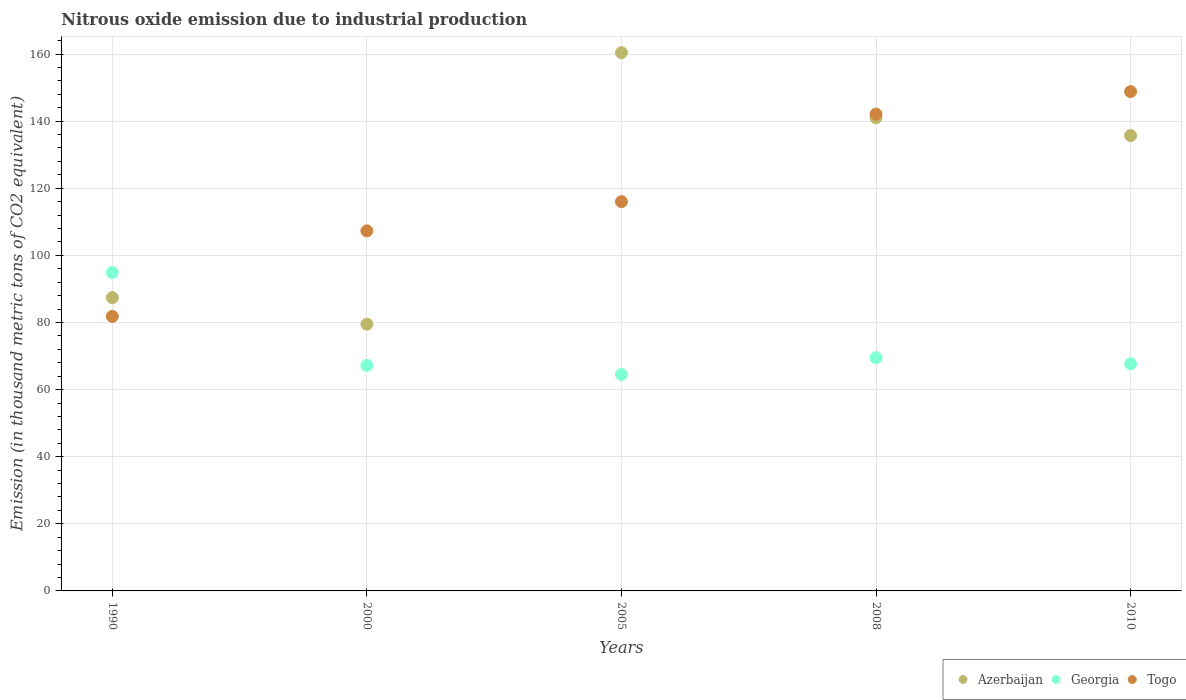What is the amount of nitrous oxide emitted in Georgia in 2000?
Your answer should be compact. 67.2. Across all years, what is the maximum amount of nitrous oxide emitted in Georgia?
Your response must be concise. 94.9. Across all years, what is the minimum amount of nitrous oxide emitted in Togo?
Keep it short and to the point. 81.8. In which year was the amount of nitrous oxide emitted in Azerbaijan maximum?
Your answer should be compact. 2005. In which year was the amount of nitrous oxide emitted in Azerbaijan minimum?
Your answer should be compact. 2000. What is the total amount of nitrous oxide emitted in Azerbaijan in the graph?
Make the answer very short. 604. What is the difference between the amount of nitrous oxide emitted in Azerbaijan in 1990 and that in 2010?
Your answer should be very brief. -48.3. What is the difference between the amount of nitrous oxide emitted in Togo in 2000 and the amount of nitrous oxide emitted in Georgia in 2010?
Ensure brevity in your answer.  39.6. What is the average amount of nitrous oxide emitted in Georgia per year?
Keep it short and to the point. 72.76. In the year 2010, what is the difference between the amount of nitrous oxide emitted in Togo and amount of nitrous oxide emitted in Georgia?
Your answer should be very brief. 81.1. In how many years, is the amount of nitrous oxide emitted in Georgia greater than 100 thousand metric tons?
Offer a very short reply. 0. What is the ratio of the amount of nitrous oxide emitted in Togo in 2008 to that in 2010?
Keep it short and to the point. 0.95. Is the amount of nitrous oxide emitted in Georgia in 2008 less than that in 2010?
Give a very brief answer. No. Is the difference between the amount of nitrous oxide emitted in Togo in 2000 and 2008 greater than the difference between the amount of nitrous oxide emitted in Georgia in 2000 and 2008?
Keep it short and to the point. No. What is the difference between the highest and the second highest amount of nitrous oxide emitted in Azerbaijan?
Provide a short and direct response. 19.4. What is the difference between the highest and the lowest amount of nitrous oxide emitted in Togo?
Offer a terse response. 67. Is the sum of the amount of nitrous oxide emitted in Togo in 2000 and 2005 greater than the maximum amount of nitrous oxide emitted in Georgia across all years?
Give a very brief answer. Yes. Does the amount of nitrous oxide emitted in Togo monotonically increase over the years?
Your response must be concise. Yes. Is the amount of nitrous oxide emitted in Azerbaijan strictly greater than the amount of nitrous oxide emitted in Togo over the years?
Ensure brevity in your answer.  No. Is the amount of nitrous oxide emitted in Togo strictly less than the amount of nitrous oxide emitted in Azerbaijan over the years?
Offer a terse response. No. How many dotlines are there?
Provide a short and direct response. 3. How many years are there in the graph?
Your response must be concise. 5. Are the values on the major ticks of Y-axis written in scientific E-notation?
Make the answer very short. No. Where does the legend appear in the graph?
Your answer should be compact. Bottom right. How many legend labels are there?
Provide a short and direct response. 3. How are the legend labels stacked?
Offer a very short reply. Horizontal. What is the title of the graph?
Offer a very short reply. Nitrous oxide emission due to industrial production. What is the label or title of the Y-axis?
Give a very brief answer. Emission (in thousand metric tons of CO2 equivalent). What is the Emission (in thousand metric tons of CO2 equivalent) of Azerbaijan in 1990?
Offer a terse response. 87.4. What is the Emission (in thousand metric tons of CO2 equivalent) of Georgia in 1990?
Make the answer very short. 94.9. What is the Emission (in thousand metric tons of CO2 equivalent) of Togo in 1990?
Provide a short and direct response. 81.8. What is the Emission (in thousand metric tons of CO2 equivalent) in Azerbaijan in 2000?
Ensure brevity in your answer.  79.5. What is the Emission (in thousand metric tons of CO2 equivalent) in Georgia in 2000?
Ensure brevity in your answer.  67.2. What is the Emission (in thousand metric tons of CO2 equivalent) in Togo in 2000?
Provide a succinct answer. 107.3. What is the Emission (in thousand metric tons of CO2 equivalent) in Azerbaijan in 2005?
Provide a succinct answer. 160.4. What is the Emission (in thousand metric tons of CO2 equivalent) of Georgia in 2005?
Offer a very short reply. 64.5. What is the Emission (in thousand metric tons of CO2 equivalent) in Togo in 2005?
Keep it short and to the point. 116. What is the Emission (in thousand metric tons of CO2 equivalent) in Azerbaijan in 2008?
Make the answer very short. 141. What is the Emission (in thousand metric tons of CO2 equivalent) in Georgia in 2008?
Give a very brief answer. 69.5. What is the Emission (in thousand metric tons of CO2 equivalent) of Togo in 2008?
Your response must be concise. 142.1. What is the Emission (in thousand metric tons of CO2 equivalent) of Azerbaijan in 2010?
Your response must be concise. 135.7. What is the Emission (in thousand metric tons of CO2 equivalent) in Georgia in 2010?
Offer a very short reply. 67.7. What is the Emission (in thousand metric tons of CO2 equivalent) in Togo in 2010?
Make the answer very short. 148.8. Across all years, what is the maximum Emission (in thousand metric tons of CO2 equivalent) in Azerbaijan?
Your answer should be very brief. 160.4. Across all years, what is the maximum Emission (in thousand metric tons of CO2 equivalent) of Georgia?
Provide a short and direct response. 94.9. Across all years, what is the maximum Emission (in thousand metric tons of CO2 equivalent) of Togo?
Provide a succinct answer. 148.8. Across all years, what is the minimum Emission (in thousand metric tons of CO2 equivalent) in Azerbaijan?
Provide a short and direct response. 79.5. Across all years, what is the minimum Emission (in thousand metric tons of CO2 equivalent) of Georgia?
Give a very brief answer. 64.5. Across all years, what is the minimum Emission (in thousand metric tons of CO2 equivalent) in Togo?
Offer a terse response. 81.8. What is the total Emission (in thousand metric tons of CO2 equivalent) of Azerbaijan in the graph?
Make the answer very short. 604. What is the total Emission (in thousand metric tons of CO2 equivalent) in Georgia in the graph?
Offer a terse response. 363.8. What is the total Emission (in thousand metric tons of CO2 equivalent) of Togo in the graph?
Your answer should be very brief. 596. What is the difference between the Emission (in thousand metric tons of CO2 equivalent) of Georgia in 1990 and that in 2000?
Provide a succinct answer. 27.7. What is the difference between the Emission (in thousand metric tons of CO2 equivalent) in Togo in 1990 and that in 2000?
Make the answer very short. -25.5. What is the difference between the Emission (in thousand metric tons of CO2 equivalent) of Azerbaijan in 1990 and that in 2005?
Provide a succinct answer. -73. What is the difference between the Emission (in thousand metric tons of CO2 equivalent) of Georgia in 1990 and that in 2005?
Keep it short and to the point. 30.4. What is the difference between the Emission (in thousand metric tons of CO2 equivalent) of Togo in 1990 and that in 2005?
Your answer should be very brief. -34.2. What is the difference between the Emission (in thousand metric tons of CO2 equivalent) in Azerbaijan in 1990 and that in 2008?
Your answer should be very brief. -53.6. What is the difference between the Emission (in thousand metric tons of CO2 equivalent) in Georgia in 1990 and that in 2008?
Make the answer very short. 25.4. What is the difference between the Emission (in thousand metric tons of CO2 equivalent) of Togo in 1990 and that in 2008?
Your answer should be very brief. -60.3. What is the difference between the Emission (in thousand metric tons of CO2 equivalent) in Azerbaijan in 1990 and that in 2010?
Your answer should be very brief. -48.3. What is the difference between the Emission (in thousand metric tons of CO2 equivalent) in Georgia in 1990 and that in 2010?
Provide a succinct answer. 27.2. What is the difference between the Emission (in thousand metric tons of CO2 equivalent) in Togo in 1990 and that in 2010?
Offer a terse response. -67. What is the difference between the Emission (in thousand metric tons of CO2 equivalent) of Azerbaijan in 2000 and that in 2005?
Ensure brevity in your answer.  -80.9. What is the difference between the Emission (in thousand metric tons of CO2 equivalent) of Georgia in 2000 and that in 2005?
Offer a very short reply. 2.7. What is the difference between the Emission (in thousand metric tons of CO2 equivalent) in Azerbaijan in 2000 and that in 2008?
Provide a succinct answer. -61.5. What is the difference between the Emission (in thousand metric tons of CO2 equivalent) of Georgia in 2000 and that in 2008?
Give a very brief answer. -2.3. What is the difference between the Emission (in thousand metric tons of CO2 equivalent) of Togo in 2000 and that in 2008?
Offer a terse response. -34.8. What is the difference between the Emission (in thousand metric tons of CO2 equivalent) of Azerbaijan in 2000 and that in 2010?
Keep it short and to the point. -56.2. What is the difference between the Emission (in thousand metric tons of CO2 equivalent) in Togo in 2000 and that in 2010?
Offer a very short reply. -41.5. What is the difference between the Emission (in thousand metric tons of CO2 equivalent) of Azerbaijan in 2005 and that in 2008?
Give a very brief answer. 19.4. What is the difference between the Emission (in thousand metric tons of CO2 equivalent) of Togo in 2005 and that in 2008?
Your answer should be compact. -26.1. What is the difference between the Emission (in thousand metric tons of CO2 equivalent) of Azerbaijan in 2005 and that in 2010?
Give a very brief answer. 24.7. What is the difference between the Emission (in thousand metric tons of CO2 equivalent) in Togo in 2005 and that in 2010?
Provide a succinct answer. -32.8. What is the difference between the Emission (in thousand metric tons of CO2 equivalent) in Togo in 2008 and that in 2010?
Offer a terse response. -6.7. What is the difference between the Emission (in thousand metric tons of CO2 equivalent) of Azerbaijan in 1990 and the Emission (in thousand metric tons of CO2 equivalent) of Georgia in 2000?
Provide a succinct answer. 20.2. What is the difference between the Emission (in thousand metric tons of CO2 equivalent) of Azerbaijan in 1990 and the Emission (in thousand metric tons of CO2 equivalent) of Togo in 2000?
Your response must be concise. -19.9. What is the difference between the Emission (in thousand metric tons of CO2 equivalent) of Georgia in 1990 and the Emission (in thousand metric tons of CO2 equivalent) of Togo in 2000?
Provide a short and direct response. -12.4. What is the difference between the Emission (in thousand metric tons of CO2 equivalent) in Azerbaijan in 1990 and the Emission (in thousand metric tons of CO2 equivalent) in Georgia in 2005?
Your answer should be compact. 22.9. What is the difference between the Emission (in thousand metric tons of CO2 equivalent) of Azerbaijan in 1990 and the Emission (in thousand metric tons of CO2 equivalent) of Togo in 2005?
Your answer should be compact. -28.6. What is the difference between the Emission (in thousand metric tons of CO2 equivalent) of Georgia in 1990 and the Emission (in thousand metric tons of CO2 equivalent) of Togo in 2005?
Offer a terse response. -21.1. What is the difference between the Emission (in thousand metric tons of CO2 equivalent) of Azerbaijan in 1990 and the Emission (in thousand metric tons of CO2 equivalent) of Togo in 2008?
Offer a very short reply. -54.7. What is the difference between the Emission (in thousand metric tons of CO2 equivalent) in Georgia in 1990 and the Emission (in thousand metric tons of CO2 equivalent) in Togo in 2008?
Your answer should be very brief. -47.2. What is the difference between the Emission (in thousand metric tons of CO2 equivalent) of Azerbaijan in 1990 and the Emission (in thousand metric tons of CO2 equivalent) of Togo in 2010?
Give a very brief answer. -61.4. What is the difference between the Emission (in thousand metric tons of CO2 equivalent) of Georgia in 1990 and the Emission (in thousand metric tons of CO2 equivalent) of Togo in 2010?
Your response must be concise. -53.9. What is the difference between the Emission (in thousand metric tons of CO2 equivalent) of Azerbaijan in 2000 and the Emission (in thousand metric tons of CO2 equivalent) of Georgia in 2005?
Give a very brief answer. 15. What is the difference between the Emission (in thousand metric tons of CO2 equivalent) of Azerbaijan in 2000 and the Emission (in thousand metric tons of CO2 equivalent) of Togo in 2005?
Keep it short and to the point. -36.5. What is the difference between the Emission (in thousand metric tons of CO2 equivalent) of Georgia in 2000 and the Emission (in thousand metric tons of CO2 equivalent) of Togo in 2005?
Your answer should be compact. -48.8. What is the difference between the Emission (in thousand metric tons of CO2 equivalent) of Azerbaijan in 2000 and the Emission (in thousand metric tons of CO2 equivalent) of Togo in 2008?
Provide a succinct answer. -62.6. What is the difference between the Emission (in thousand metric tons of CO2 equivalent) in Georgia in 2000 and the Emission (in thousand metric tons of CO2 equivalent) in Togo in 2008?
Provide a succinct answer. -74.9. What is the difference between the Emission (in thousand metric tons of CO2 equivalent) of Azerbaijan in 2000 and the Emission (in thousand metric tons of CO2 equivalent) of Georgia in 2010?
Provide a short and direct response. 11.8. What is the difference between the Emission (in thousand metric tons of CO2 equivalent) in Azerbaijan in 2000 and the Emission (in thousand metric tons of CO2 equivalent) in Togo in 2010?
Give a very brief answer. -69.3. What is the difference between the Emission (in thousand metric tons of CO2 equivalent) of Georgia in 2000 and the Emission (in thousand metric tons of CO2 equivalent) of Togo in 2010?
Your answer should be very brief. -81.6. What is the difference between the Emission (in thousand metric tons of CO2 equivalent) of Azerbaijan in 2005 and the Emission (in thousand metric tons of CO2 equivalent) of Georgia in 2008?
Make the answer very short. 90.9. What is the difference between the Emission (in thousand metric tons of CO2 equivalent) of Georgia in 2005 and the Emission (in thousand metric tons of CO2 equivalent) of Togo in 2008?
Ensure brevity in your answer.  -77.6. What is the difference between the Emission (in thousand metric tons of CO2 equivalent) in Azerbaijan in 2005 and the Emission (in thousand metric tons of CO2 equivalent) in Georgia in 2010?
Your response must be concise. 92.7. What is the difference between the Emission (in thousand metric tons of CO2 equivalent) of Azerbaijan in 2005 and the Emission (in thousand metric tons of CO2 equivalent) of Togo in 2010?
Ensure brevity in your answer.  11.6. What is the difference between the Emission (in thousand metric tons of CO2 equivalent) in Georgia in 2005 and the Emission (in thousand metric tons of CO2 equivalent) in Togo in 2010?
Make the answer very short. -84.3. What is the difference between the Emission (in thousand metric tons of CO2 equivalent) of Azerbaijan in 2008 and the Emission (in thousand metric tons of CO2 equivalent) of Georgia in 2010?
Provide a short and direct response. 73.3. What is the difference between the Emission (in thousand metric tons of CO2 equivalent) of Azerbaijan in 2008 and the Emission (in thousand metric tons of CO2 equivalent) of Togo in 2010?
Provide a succinct answer. -7.8. What is the difference between the Emission (in thousand metric tons of CO2 equivalent) of Georgia in 2008 and the Emission (in thousand metric tons of CO2 equivalent) of Togo in 2010?
Keep it short and to the point. -79.3. What is the average Emission (in thousand metric tons of CO2 equivalent) of Azerbaijan per year?
Ensure brevity in your answer.  120.8. What is the average Emission (in thousand metric tons of CO2 equivalent) in Georgia per year?
Provide a succinct answer. 72.76. What is the average Emission (in thousand metric tons of CO2 equivalent) of Togo per year?
Provide a short and direct response. 119.2. In the year 1990, what is the difference between the Emission (in thousand metric tons of CO2 equivalent) in Azerbaijan and Emission (in thousand metric tons of CO2 equivalent) in Togo?
Give a very brief answer. 5.6. In the year 1990, what is the difference between the Emission (in thousand metric tons of CO2 equivalent) of Georgia and Emission (in thousand metric tons of CO2 equivalent) of Togo?
Ensure brevity in your answer.  13.1. In the year 2000, what is the difference between the Emission (in thousand metric tons of CO2 equivalent) in Azerbaijan and Emission (in thousand metric tons of CO2 equivalent) in Togo?
Make the answer very short. -27.8. In the year 2000, what is the difference between the Emission (in thousand metric tons of CO2 equivalent) in Georgia and Emission (in thousand metric tons of CO2 equivalent) in Togo?
Your answer should be very brief. -40.1. In the year 2005, what is the difference between the Emission (in thousand metric tons of CO2 equivalent) in Azerbaijan and Emission (in thousand metric tons of CO2 equivalent) in Georgia?
Offer a terse response. 95.9. In the year 2005, what is the difference between the Emission (in thousand metric tons of CO2 equivalent) in Azerbaijan and Emission (in thousand metric tons of CO2 equivalent) in Togo?
Provide a short and direct response. 44.4. In the year 2005, what is the difference between the Emission (in thousand metric tons of CO2 equivalent) in Georgia and Emission (in thousand metric tons of CO2 equivalent) in Togo?
Give a very brief answer. -51.5. In the year 2008, what is the difference between the Emission (in thousand metric tons of CO2 equivalent) of Azerbaijan and Emission (in thousand metric tons of CO2 equivalent) of Georgia?
Ensure brevity in your answer.  71.5. In the year 2008, what is the difference between the Emission (in thousand metric tons of CO2 equivalent) in Azerbaijan and Emission (in thousand metric tons of CO2 equivalent) in Togo?
Your answer should be very brief. -1.1. In the year 2008, what is the difference between the Emission (in thousand metric tons of CO2 equivalent) in Georgia and Emission (in thousand metric tons of CO2 equivalent) in Togo?
Provide a short and direct response. -72.6. In the year 2010, what is the difference between the Emission (in thousand metric tons of CO2 equivalent) of Georgia and Emission (in thousand metric tons of CO2 equivalent) of Togo?
Keep it short and to the point. -81.1. What is the ratio of the Emission (in thousand metric tons of CO2 equivalent) of Azerbaijan in 1990 to that in 2000?
Provide a short and direct response. 1.1. What is the ratio of the Emission (in thousand metric tons of CO2 equivalent) in Georgia in 1990 to that in 2000?
Provide a short and direct response. 1.41. What is the ratio of the Emission (in thousand metric tons of CO2 equivalent) of Togo in 1990 to that in 2000?
Your answer should be compact. 0.76. What is the ratio of the Emission (in thousand metric tons of CO2 equivalent) in Azerbaijan in 1990 to that in 2005?
Keep it short and to the point. 0.54. What is the ratio of the Emission (in thousand metric tons of CO2 equivalent) in Georgia in 1990 to that in 2005?
Ensure brevity in your answer.  1.47. What is the ratio of the Emission (in thousand metric tons of CO2 equivalent) in Togo in 1990 to that in 2005?
Offer a terse response. 0.71. What is the ratio of the Emission (in thousand metric tons of CO2 equivalent) in Azerbaijan in 1990 to that in 2008?
Provide a succinct answer. 0.62. What is the ratio of the Emission (in thousand metric tons of CO2 equivalent) in Georgia in 1990 to that in 2008?
Make the answer very short. 1.37. What is the ratio of the Emission (in thousand metric tons of CO2 equivalent) in Togo in 1990 to that in 2008?
Keep it short and to the point. 0.58. What is the ratio of the Emission (in thousand metric tons of CO2 equivalent) in Azerbaijan in 1990 to that in 2010?
Make the answer very short. 0.64. What is the ratio of the Emission (in thousand metric tons of CO2 equivalent) in Georgia in 1990 to that in 2010?
Provide a succinct answer. 1.4. What is the ratio of the Emission (in thousand metric tons of CO2 equivalent) in Togo in 1990 to that in 2010?
Provide a short and direct response. 0.55. What is the ratio of the Emission (in thousand metric tons of CO2 equivalent) in Azerbaijan in 2000 to that in 2005?
Ensure brevity in your answer.  0.5. What is the ratio of the Emission (in thousand metric tons of CO2 equivalent) of Georgia in 2000 to that in 2005?
Give a very brief answer. 1.04. What is the ratio of the Emission (in thousand metric tons of CO2 equivalent) of Togo in 2000 to that in 2005?
Your answer should be compact. 0.93. What is the ratio of the Emission (in thousand metric tons of CO2 equivalent) in Azerbaijan in 2000 to that in 2008?
Provide a succinct answer. 0.56. What is the ratio of the Emission (in thousand metric tons of CO2 equivalent) of Georgia in 2000 to that in 2008?
Make the answer very short. 0.97. What is the ratio of the Emission (in thousand metric tons of CO2 equivalent) in Togo in 2000 to that in 2008?
Offer a very short reply. 0.76. What is the ratio of the Emission (in thousand metric tons of CO2 equivalent) in Azerbaijan in 2000 to that in 2010?
Ensure brevity in your answer.  0.59. What is the ratio of the Emission (in thousand metric tons of CO2 equivalent) in Georgia in 2000 to that in 2010?
Offer a very short reply. 0.99. What is the ratio of the Emission (in thousand metric tons of CO2 equivalent) in Togo in 2000 to that in 2010?
Your response must be concise. 0.72. What is the ratio of the Emission (in thousand metric tons of CO2 equivalent) in Azerbaijan in 2005 to that in 2008?
Make the answer very short. 1.14. What is the ratio of the Emission (in thousand metric tons of CO2 equivalent) of Georgia in 2005 to that in 2008?
Ensure brevity in your answer.  0.93. What is the ratio of the Emission (in thousand metric tons of CO2 equivalent) in Togo in 2005 to that in 2008?
Provide a succinct answer. 0.82. What is the ratio of the Emission (in thousand metric tons of CO2 equivalent) of Azerbaijan in 2005 to that in 2010?
Your answer should be very brief. 1.18. What is the ratio of the Emission (in thousand metric tons of CO2 equivalent) in Georgia in 2005 to that in 2010?
Offer a very short reply. 0.95. What is the ratio of the Emission (in thousand metric tons of CO2 equivalent) in Togo in 2005 to that in 2010?
Provide a short and direct response. 0.78. What is the ratio of the Emission (in thousand metric tons of CO2 equivalent) of Azerbaijan in 2008 to that in 2010?
Your answer should be compact. 1.04. What is the ratio of the Emission (in thousand metric tons of CO2 equivalent) of Georgia in 2008 to that in 2010?
Your answer should be very brief. 1.03. What is the ratio of the Emission (in thousand metric tons of CO2 equivalent) of Togo in 2008 to that in 2010?
Provide a succinct answer. 0.95. What is the difference between the highest and the second highest Emission (in thousand metric tons of CO2 equivalent) of Azerbaijan?
Your answer should be compact. 19.4. What is the difference between the highest and the second highest Emission (in thousand metric tons of CO2 equivalent) of Georgia?
Give a very brief answer. 25.4. What is the difference between the highest and the lowest Emission (in thousand metric tons of CO2 equivalent) of Azerbaijan?
Your answer should be compact. 80.9. What is the difference between the highest and the lowest Emission (in thousand metric tons of CO2 equivalent) of Georgia?
Provide a short and direct response. 30.4. What is the difference between the highest and the lowest Emission (in thousand metric tons of CO2 equivalent) of Togo?
Keep it short and to the point. 67. 